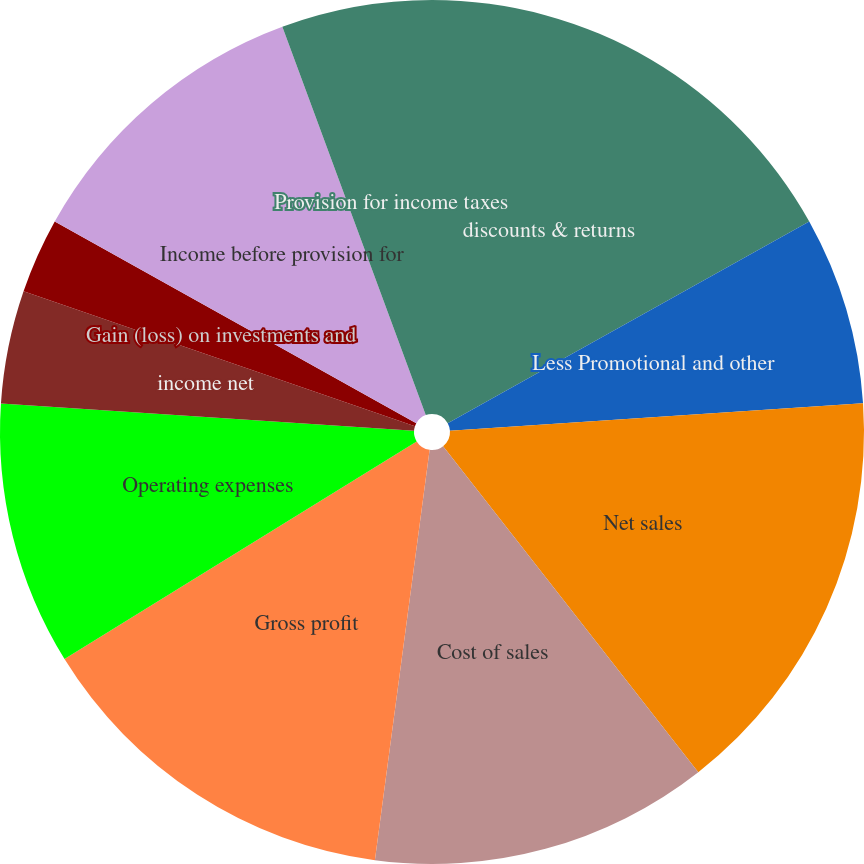Convert chart. <chart><loc_0><loc_0><loc_500><loc_500><pie_chart><fcel>discounts & returns<fcel>Less Promotional and other<fcel>Net sales<fcel>Cost of sales<fcel>Gross profit<fcel>Operating expenses<fcel>income net<fcel>Gain (loss) on investments and<fcel>Income before provision for<fcel>Provision for income taxes<nl><fcel>16.9%<fcel>7.04%<fcel>15.49%<fcel>12.68%<fcel>14.08%<fcel>9.86%<fcel>4.23%<fcel>2.82%<fcel>11.27%<fcel>5.63%<nl></chart> 